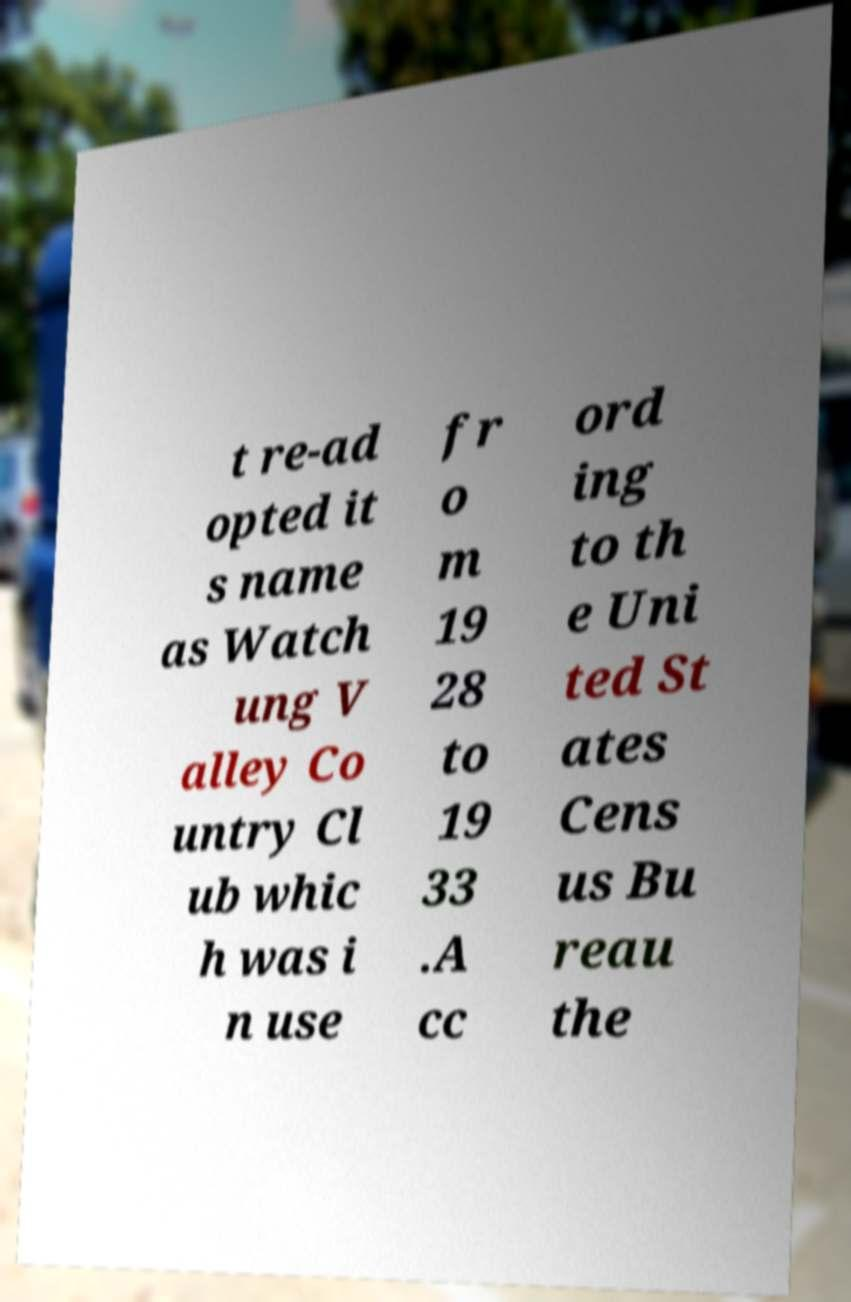Can you read and provide the text displayed in the image?This photo seems to have some interesting text. Can you extract and type it out for me? t re-ad opted it s name as Watch ung V alley Co untry Cl ub whic h was i n use fr o m 19 28 to 19 33 .A cc ord ing to th e Uni ted St ates Cens us Bu reau the 